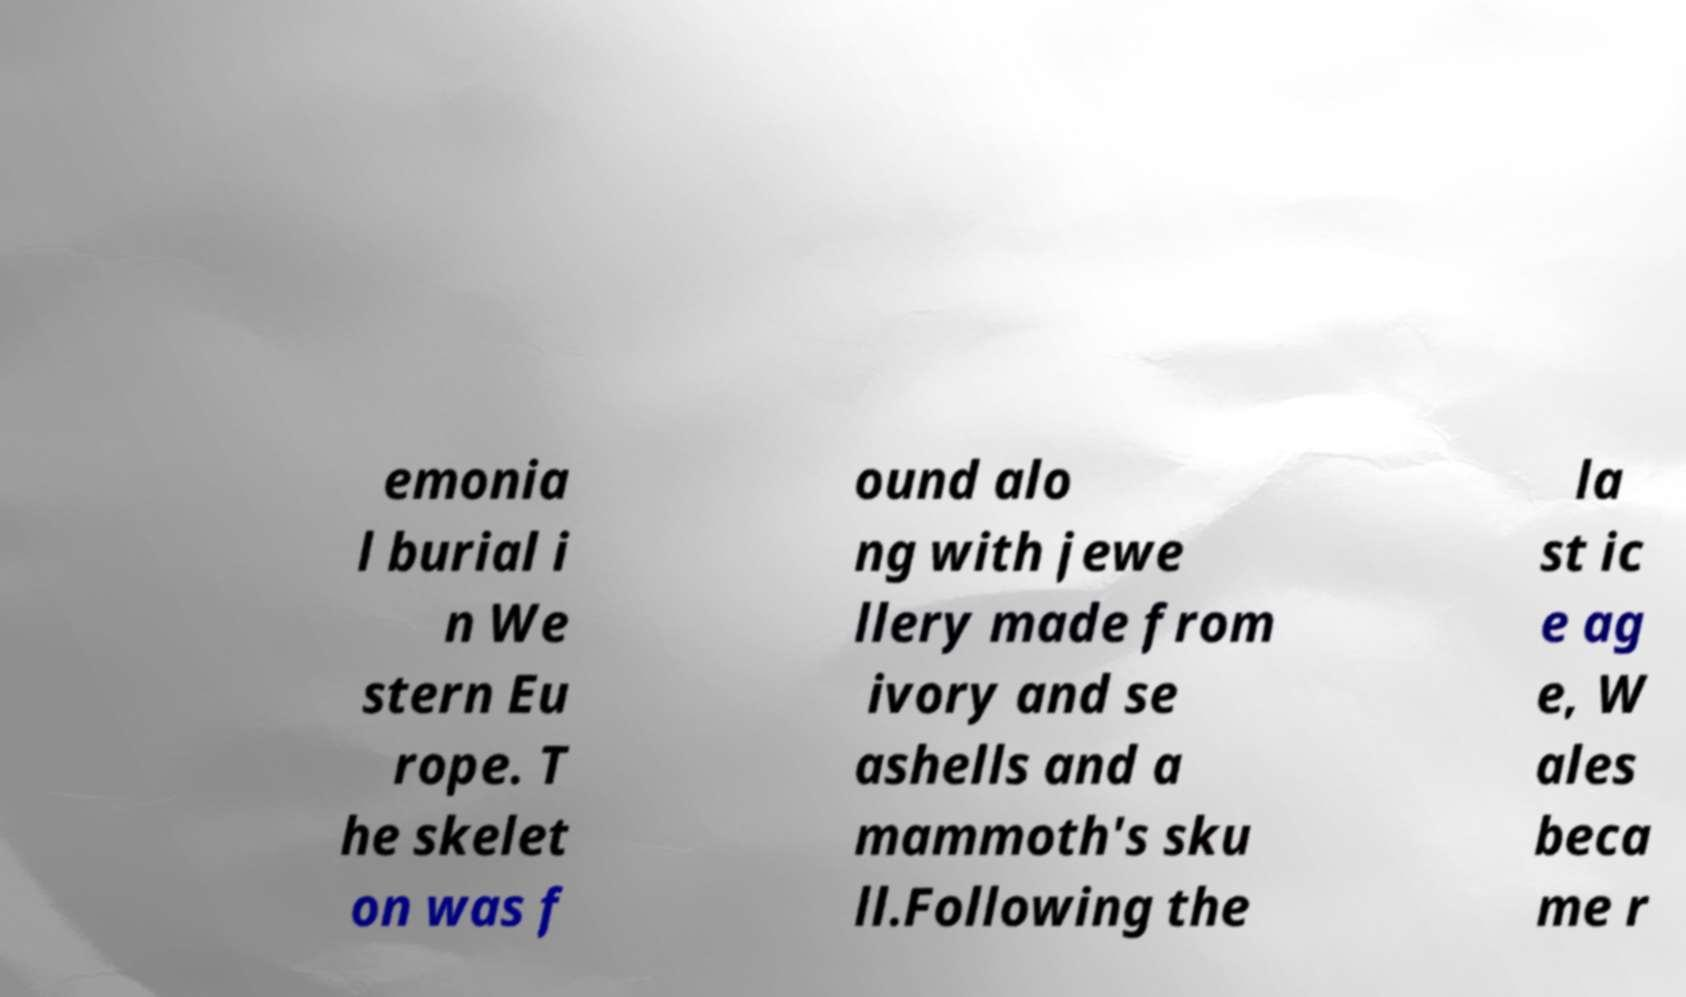There's text embedded in this image that I need extracted. Can you transcribe it verbatim? emonia l burial i n We stern Eu rope. T he skelet on was f ound alo ng with jewe llery made from ivory and se ashells and a mammoth's sku ll.Following the la st ic e ag e, W ales beca me r 